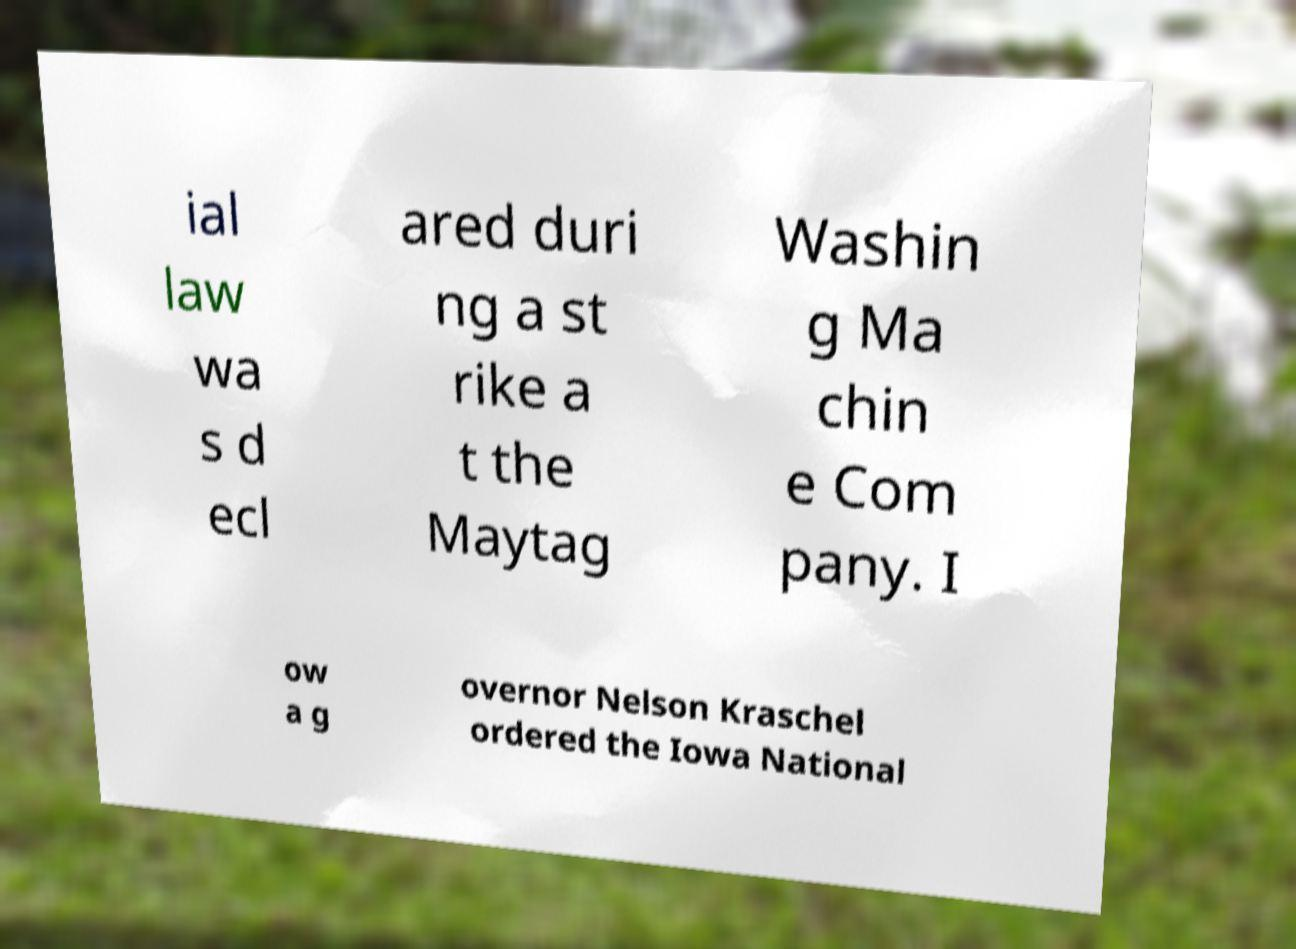Please identify and transcribe the text found in this image. ial law wa s d ecl ared duri ng a st rike a t the Maytag Washin g Ma chin e Com pany. I ow a g overnor Nelson Kraschel ordered the Iowa National 